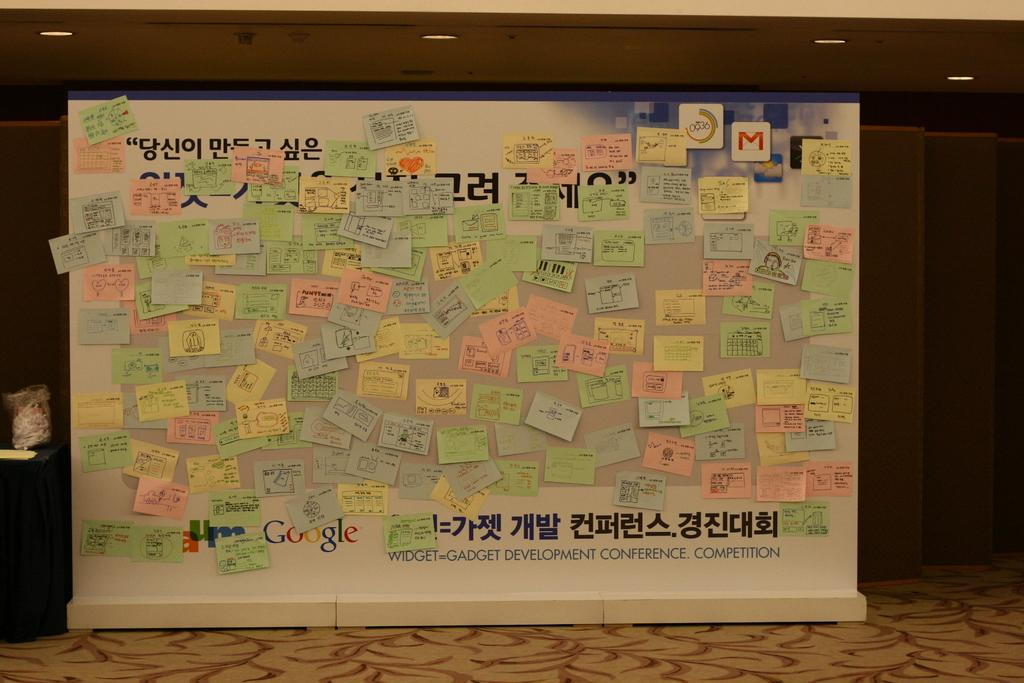<image>
Present a compact description of the photo's key features. Bulletin board with many notes and the words "Widget Gadget Development Conference Competition". 